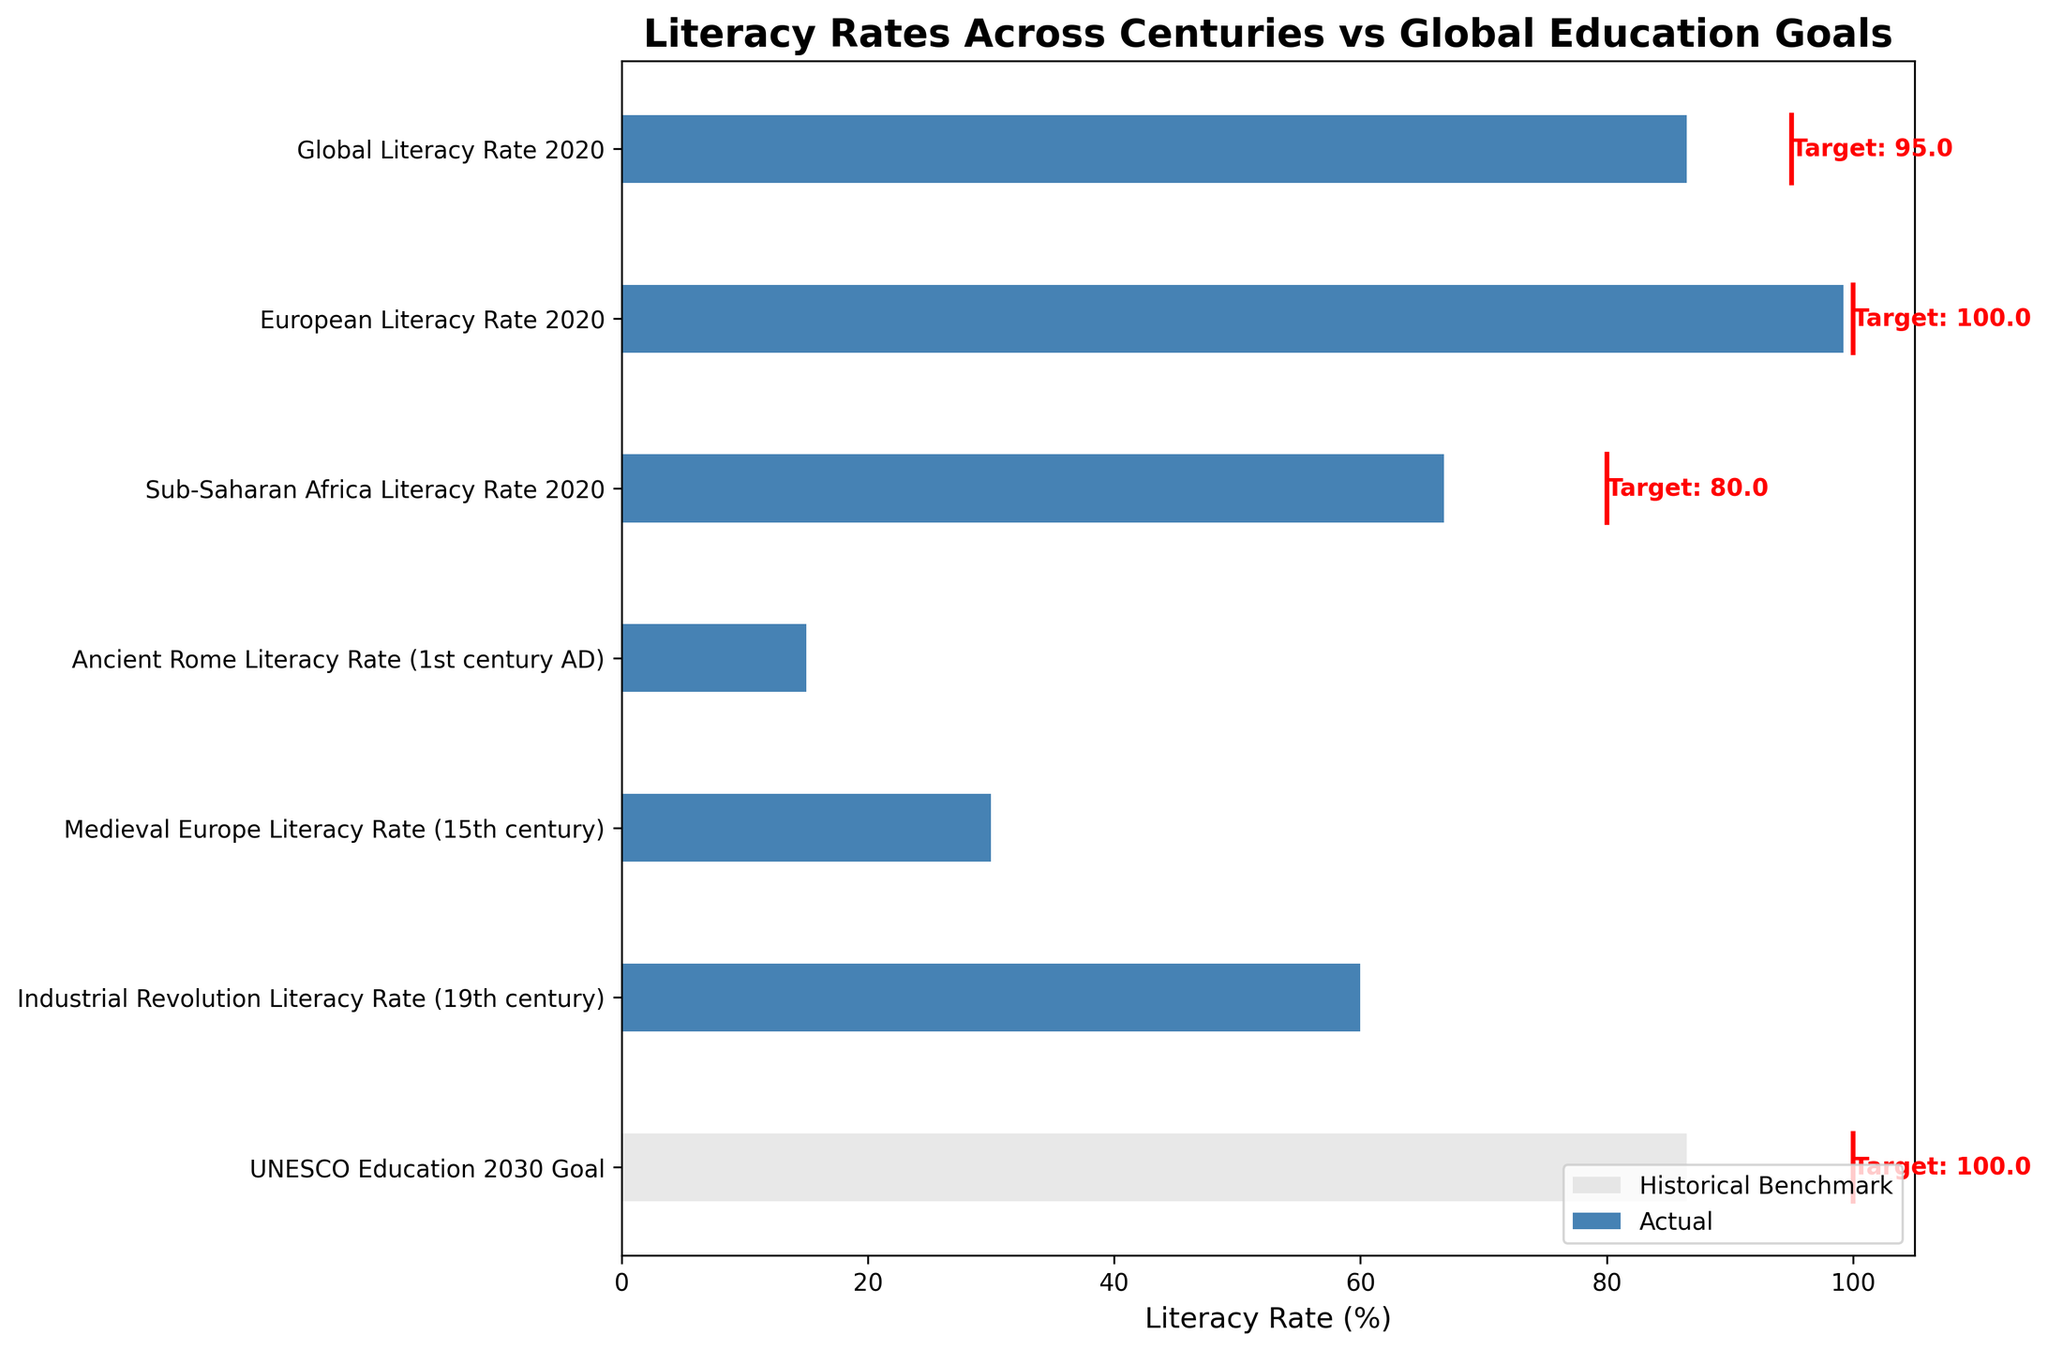What's the title of the figure? The title is displayed at the top of the figure, which describes the main theme or subject of the chart.
Answer: Literacy Rates Across Centuries vs Global Education Goals What colors represent the actual values and historical benchmarks? By observing the bars in the figure, you can see that the actual values are represented in blue and the historical benchmarks are in light gray.
Answer: Blue and light gray Which category has the highest actual literacy rate in 2020? From the bars representing 'Actual' values, we observe that the European Literacy Rate 2020 has the highest literacy rate among the categories.
Answer: European Literacy Rate 2020 What's the difference between the literacy rate target and actual rate for Sub-Saharan Africa in 2020? The actual literacy rate for Sub-Saharan Africa is 66.8%, and the target is 80%. The difference is 80% - 66.8%.
Answer: 13.2% Compare the actual literacy rate in 2020 with the historical benchmark for Sub-Saharan Africa. Which one is higher and by how much? The actual literacy rate for Sub-Saharan Africa in 2020 is 66.8%, while the historical benchmark is 59%. The actual rate is higher by 66.8% - 59%.
Answer: 7.8% What is the target literacy rate for UNESCO Education 2030 Goal? The target values are indicated in red text next to the respective categories. For UNESCO Education 2030 Goal, the target is listed.
Answer: 100% How does the literacy rate in Ancient Rome (1st century AD) compare to the Medieval Europe (15th century)? The bar representing Ancient Rome (1st century AD) has a literacy rate of 15%, whereas Medieval Europe (15th century) has a literacy rate of 30%. Comparing these, Medieval Europe has a higher literacy rate.
Answer: Medieval Europe is higher by 15% What's the average actual literacy rate in 2020 across the listed regions? The actual rates for 2020 are: Global 86.5%, European 99.2%, and Sub-Saharan Africa 66.8%. Summing these up and dividing them by 3 gives the average: (86.5 + 99.2 + 66.8) / 3.
Answer: 84.17% How does the literacy rate in the Industrial Revolution (19th century) compare to the historical benchmark of Global Literacy Rate 2020? The literacy rate during the Industrial Revolution is 60%, while the historical benchmark for Global Literacy Rate 2020 is 82%. Comparing these, the historical benchmark is higher.
Answer: Historical benchmark is higher by 22% 